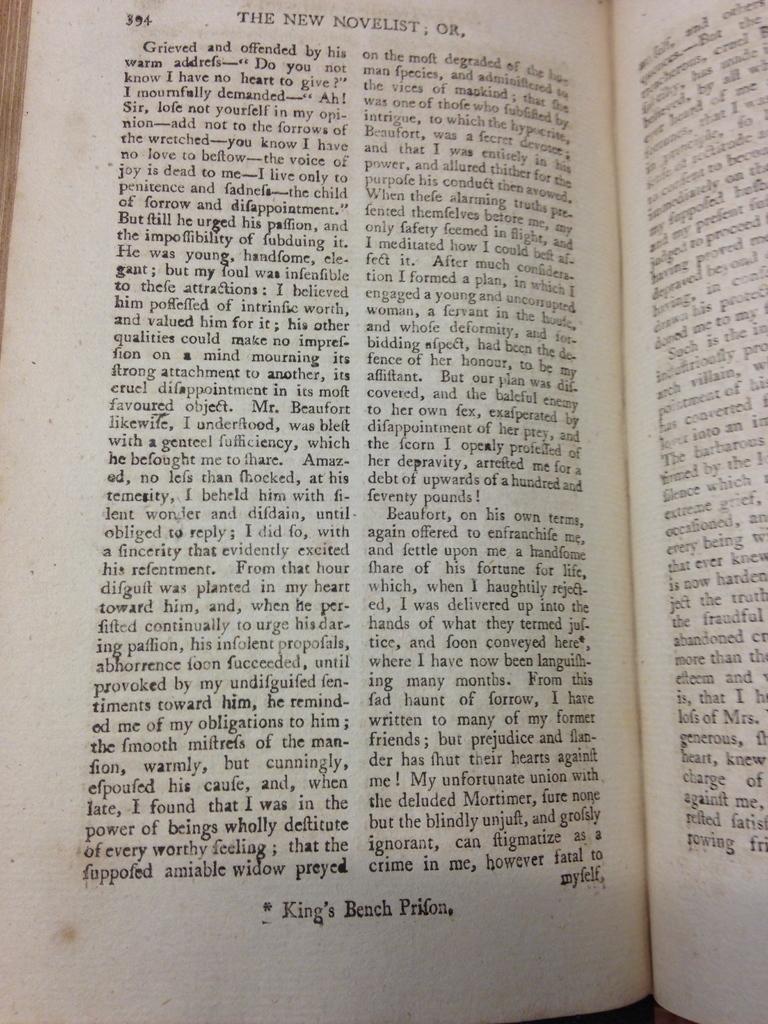What does the bottom of the page read?
Your answer should be very brief. King's bench prifon. What kind of book is this?
Your response must be concise. The new novelist. 